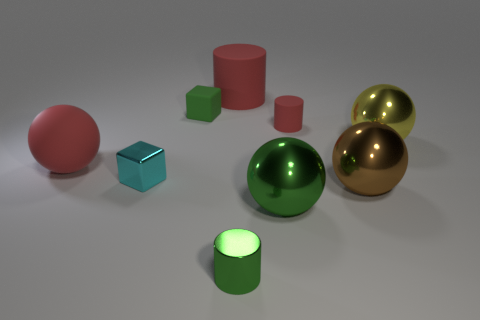Subtract all tiny rubber cylinders. How many cylinders are left? 2 Subtract all yellow balls. How many balls are left? 3 Add 1 red matte spheres. How many objects exist? 10 Subtract all blocks. How many objects are left? 7 Subtract 1 cylinders. How many cylinders are left? 2 Subtract all purple cubes. Subtract all blue balls. How many cubes are left? 2 Subtract all yellow spheres. How many blue blocks are left? 0 Subtract all big rubber spheres. Subtract all metal spheres. How many objects are left? 5 Add 7 big green shiny balls. How many big green shiny balls are left? 8 Add 4 tiny gray rubber blocks. How many tiny gray rubber blocks exist? 4 